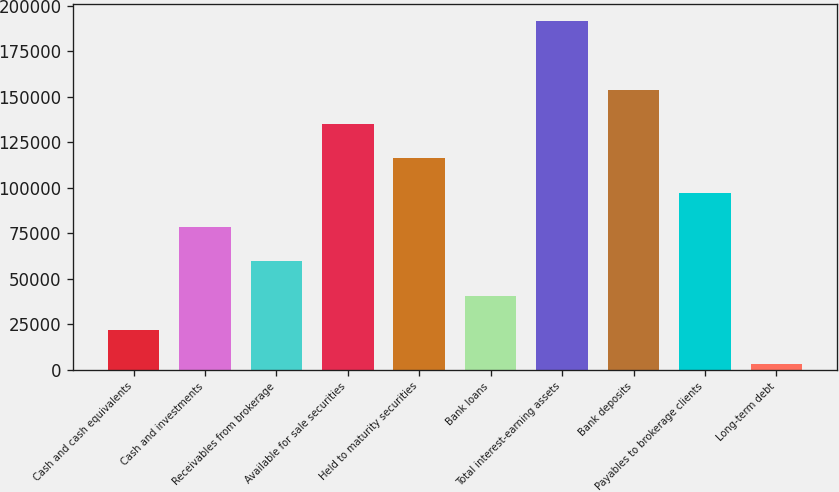Convert chart. <chart><loc_0><loc_0><loc_500><loc_500><bar_chart><fcel>Cash and cash equivalents<fcel>Cash and investments<fcel>Receivables from brokerage<fcel>Available for sale securities<fcel>Held to maturity securities<fcel>Bank loans<fcel>Total interest-earning assets<fcel>Bank deposits<fcel>Payables to brokerage clients<fcel>Long-term debt<nl><fcel>21744.2<fcel>78348.8<fcel>59480.6<fcel>134953<fcel>116085<fcel>40612.4<fcel>191558<fcel>153822<fcel>97217<fcel>2876<nl></chart> 